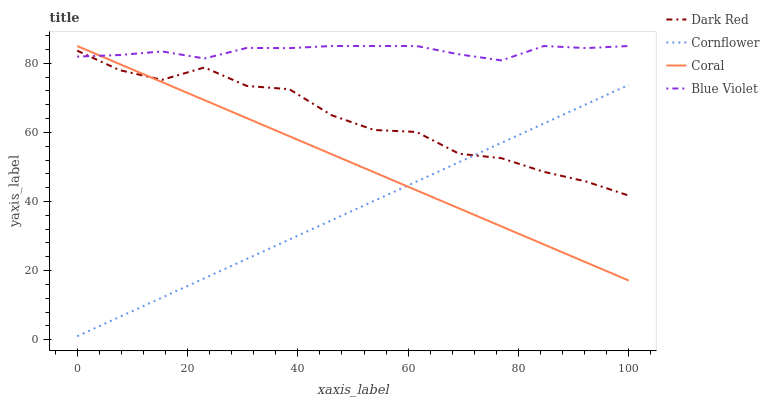Does Cornflower have the minimum area under the curve?
Answer yes or no. Yes. Does Blue Violet have the maximum area under the curve?
Answer yes or no. Yes. Does Coral have the minimum area under the curve?
Answer yes or no. No. Does Coral have the maximum area under the curve?
Answer yes or no. No. Is Cornflower the smoothest?
Answer yes or no. Yes. Is Dark Red the roughest?
Answer yes or no. Yes. Is Coral the smoothest?
Answer yes or no. No. Is Coral the roughest?
Answer yes or no. No. Does Cornflower have the lowest value?
Answer yes or no. Yes. Does Coral have the lowest value?
Answer yes or no. No. Does Blue Violet have the highest value?
Answer yes or no. Yes. Does Cornflower have the highest value?
Answer yes or no. No. Is Cornflower less than Blue Violet?
Answer yes or no. Yes. Is Blue Violet greater than Cornflower?
Answer yes or no. Yes. Does Dark Red intersect Cornflower?
Answer yes or no. Yes. Is Dark Red less than Cornflower?
Answer yes or no. No. Is Dark Red greater than Cornflower?
Answer yes or no. No. Does Cornflower intersect Blue Violet?
Answer yes or no. No. 